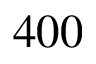Convert formula to latex. <formula><loc_0><loc_0><loc_500><loc_500>4 0 0</formula> 